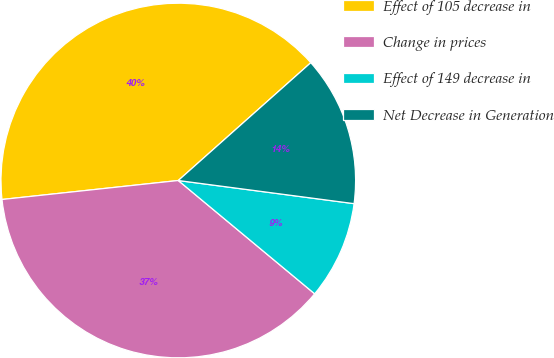<chart> <loc_0><loc_0><loc_500><loc_500><pie_chart><fcel>Effect of 105 decrease in<fcel>Change in prices<fcel>Effect of 149 decrease in<fcel>Net Decrease in Generation<nl><fcel>40.14%<fcel>37.26%<fcel>8.95%<fcel>13.65%<nl></chart> 